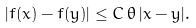<formula> <loc_0><loc_0><loc_500><loc_500>| f ( x ) - f ( y ) | \leq C \, \theta \, | x - y | .</formula> 